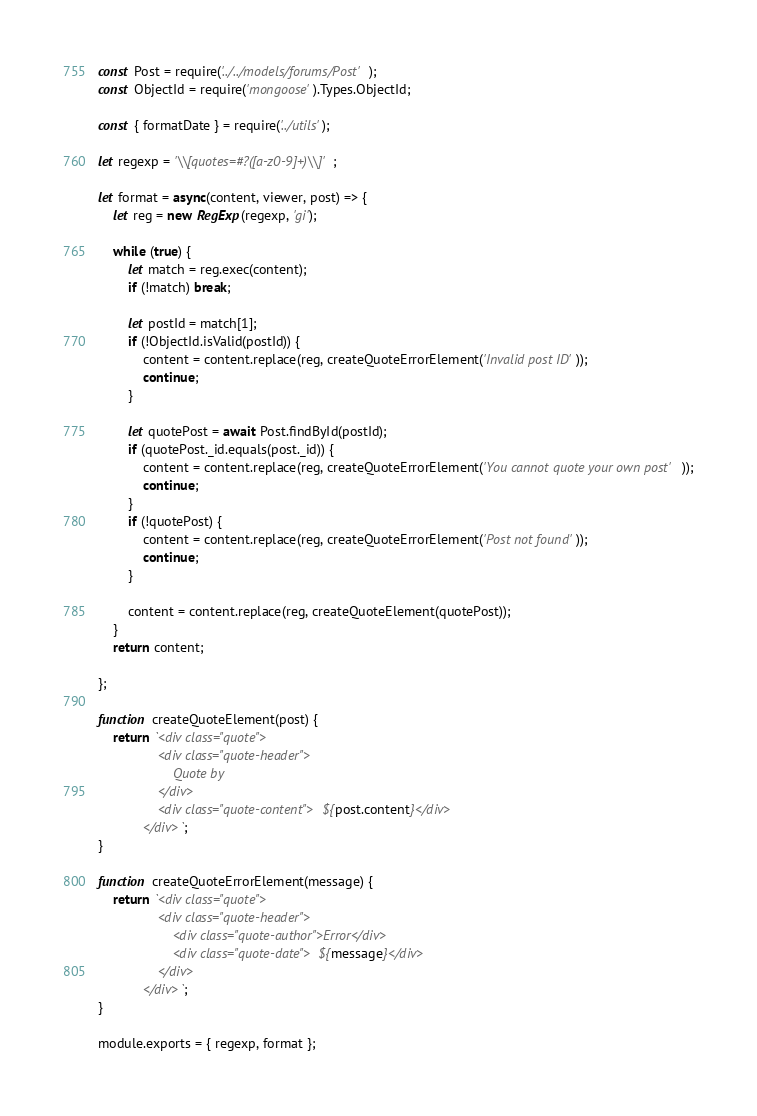Convert code to text. <code><loc_0><loc_0><loc_500><loc_500><_JavaScript_>const Post = require('../../models/forums/Post');
const ObjectId = require('mongoose').Types.ObjectId;

const { formatDate } = require('../utils');

let regexp = '\\[quotes=#?([a-z0-9]+)\\]';

let format = async(content, viewer, post) => {
    let reg = new RegExp(regexp, 'gi');

    while (true) {
        let match = reg.exec(content);
        if (!match) break;

        let postId = match[1];
        if (!ObjectId.isValid(postId)) {
            content = content.replace(reg, createQuoteErrorElement('Invalid post ID'));
            continue;
        }

        let quotePost = await Post.findById(postId);
        if (quotePost._id.equals(post._id)) {
            content = content.replace(reg, createQuoteErrorElement('You cannot quote your own post'));
            continue;
        }
        if (!quotePost) {
            content = content.replace(reg, createQuoteErrorElement('Post not found'));
            continue;
        }

        content = content.replace(reg, createQuoteElement(quotePost));
    }
    return content;

};

function createQuoteElement(post) {
    return `<div class="quote">
                <div class="quote-header">
                    Quote by
                </div>
                <div class="quote-content">${post.content}</div>
            </div>`;
}

function createQuoteErrorElement(message) {
    return `<div class="quote">
                <div class="quote-header">
                    <div class="quote-author">Error</div>
                    <div class="quote-date">${message}</div>
                </div>
            </div>`;
}

module.exports = { regexp, format };</code> 